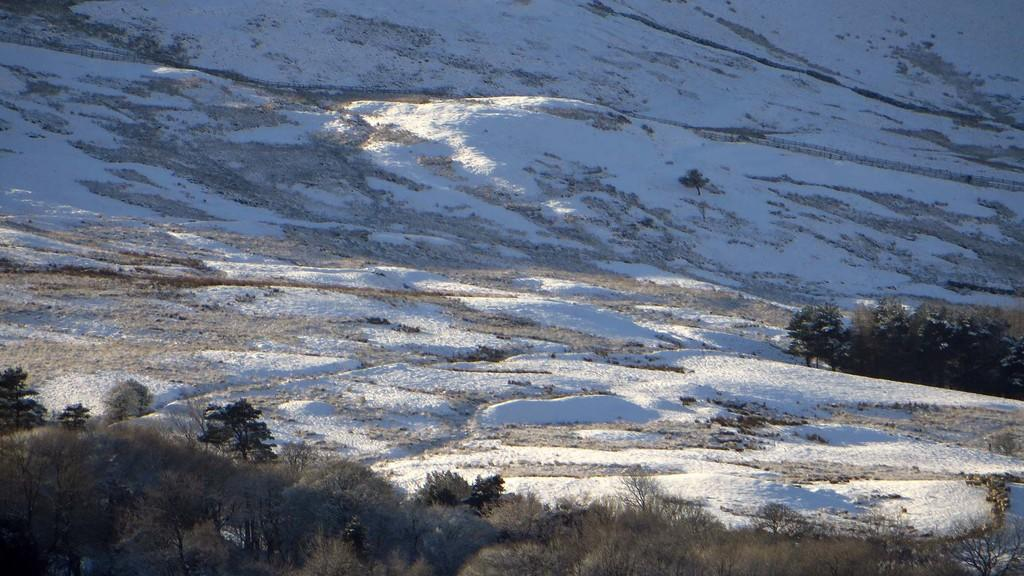What type of vegetation can be seen in the image? There are plants and trees in the image. Can you describe the ground in the image? Snow is present on the ground in the image. How does the friend react to the rail in the image? There is no friend or rail present in the image. What type of crush is visible in the image? There is no crush present in the image. 